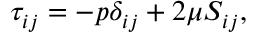Convert formula to latex. <formula><loc_0><loc_0><loc_500><loc_500>\tau _ { i j } = - p \delta _ { i j } + 2 \mu S _ { i j } ,</formula> 